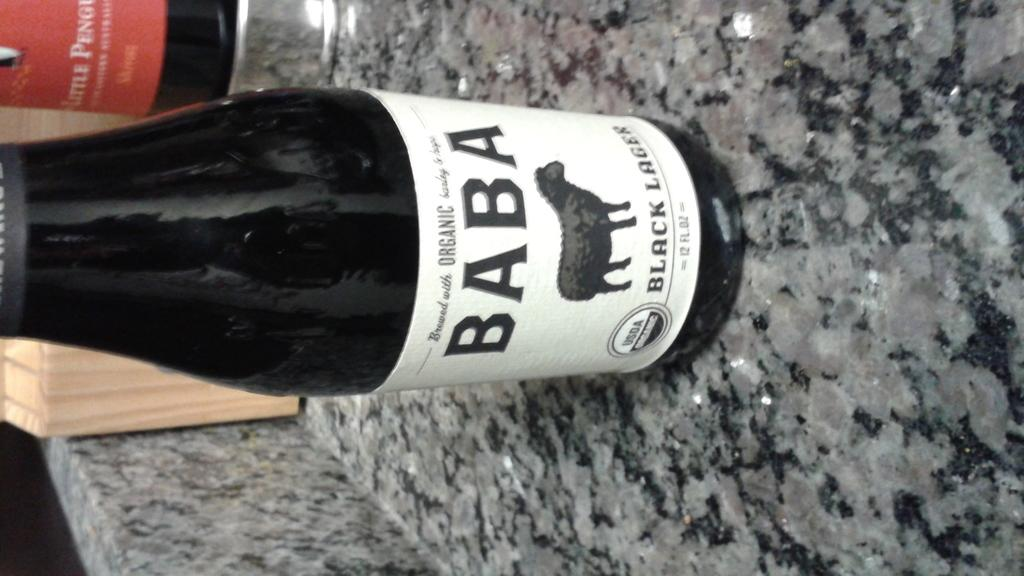<image>
Provide a brief description of the given image. A bottle of Baba Black beer on a granite counter. 